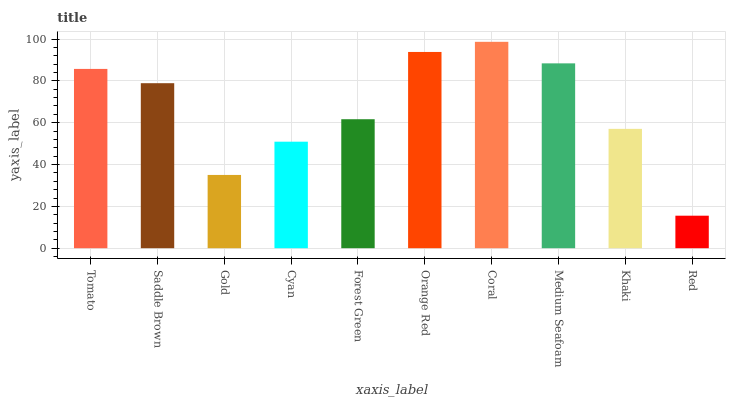Is Red the minimum?
Answer yes or no. Yes. Is Coral the maximum?
Answer yes or no. Yes. Is Saddle Brown the minimum?
Answer yes or no. No. Is Saddle Brown the maximum?
Answer yes or no. No. Is Tomato greater than Saddle Brown?
Answer yes or no. Yes. Is Saddle Brown less than Tomato?
Answer yes or no. Yes. Is Saddle Brown greater than Tomato?
Answer yes or no. No. Is Tomato less than Saddle Brown?
Answer yes or no. No. Is Saddle Brown the high median?
Answer yes or no. Yes. Is Forest Green the low median?
Answer yes or no. Yes. Is Gold the high median?
Answer yes or no. No. Is Medium Seafoam the low median?
Answer yes or no. No. 